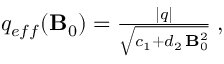Convert formula to latex. <formula><loc_0><loc_0><loc_500><loc_500>\begin{array} { r } { q _ { e f f } ( { B } _ { 0 } ) = \frac { | q | } { \sqrt { c _ { 1 } + d _ { 2 } \, { { B } _ { 0 } ^ { 2 } } } } \, , } \end{array}</formula> 